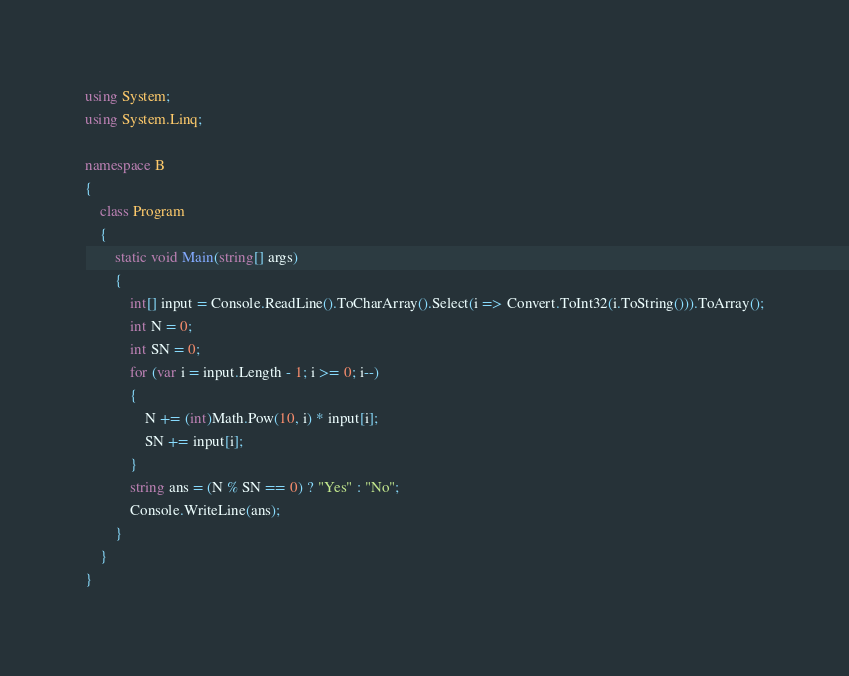Convert code to text. <code><loc_0><loc_0><loc_500><loc_500><_C#_>using System;
using System.Linq;

namespace B
{
    class Program
    {
        static void Main(string[] args)
        {
            int[] input = Console.ReadLine().ToCharArray().Select(i => Convert.ToInt32(i.ToString())).ToArray();
            int N = 0;
            int SN = 0;
            for (var i = input.Length - 1; i >= 0; i--)
            {
                N += (int)Math.Pow(10, i) * input[i];
                SN += input[i];
            }
            string ans = (N % SN == 0) ? "Yes" : "No";
            Console.WriteLine(ans);
        }
    }
}
</code> 